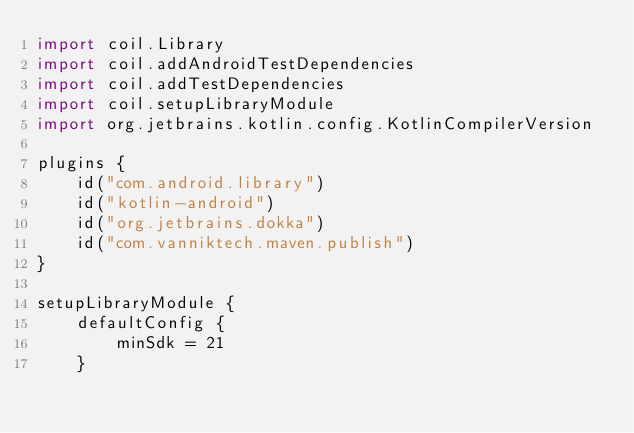<code> <loc_0><loc_0><loc_500><loc_500><_Kotlin_>import coil.Library
import coil.addAndroidTestDependencies
import coil.addTestDependencies
import coil.setupLibraryModule
import org.jetbrains.kotlin.config.KotlinCompilerVersion

plugins {
    id("com.android.library")
    id("kotlin-android")
    id("org.jetbrains.dokka")
    id("com.vanniktech.maven.publish")
}

setupLibraryModule {
    defaultConfig {
        minSdk = 21
    }</code> 